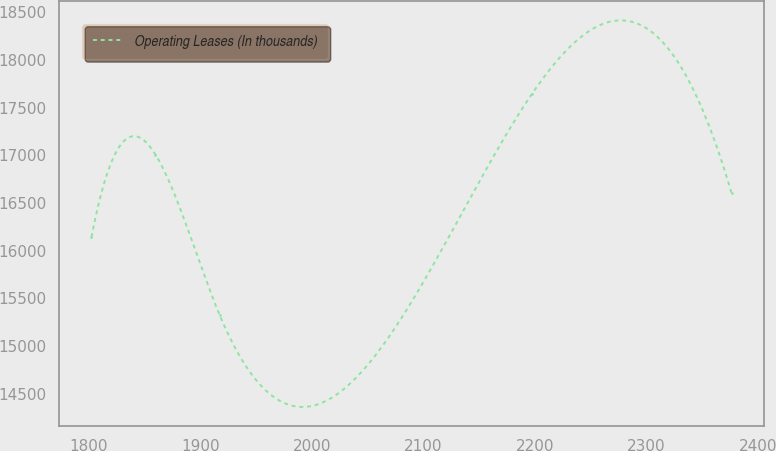Convert chart to OTSL. <chart><loc_0><loc_0><loc_500><loc_500><line_chart><ecel><fcel>Operating Leases (In thousands)<nl><fcel>1802.38<fcel>16142<nl><fcel>1859.8<fcel>17006.8<nl><fcel>1917.22<fcel>15328.2<nl><fcel>2197.19<fcel>17637.6<nl><fcel>2376.59<fcel>16602.7<nl></chart> 